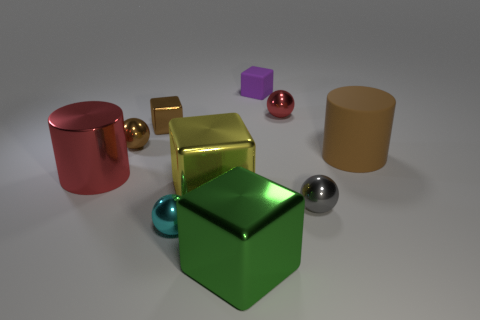Subtract all tiny purple blocks. How many blocks are left? 3 Subtract all purple blocks. How many blocks are left? 3 Subtract all spheres. How many objects are left? 6 Add 3 balls. How many balls exist? 7 Subtract 1 purple cubes. How many objects are left? 9 Subtract 3 spheres. How many spheres are left? 1 Subtract all cyan cylinders. Subtract all green balls. How many cylinders are left? 2 Subtract all yellow cylinders. How many blue cubes are left? 0 Subtract all small yellow balls. Subtract all purple matte blocks. How many objects are left? 9 Add 7 tiny brown spheres. How many tiny brown spheres are left? 8 